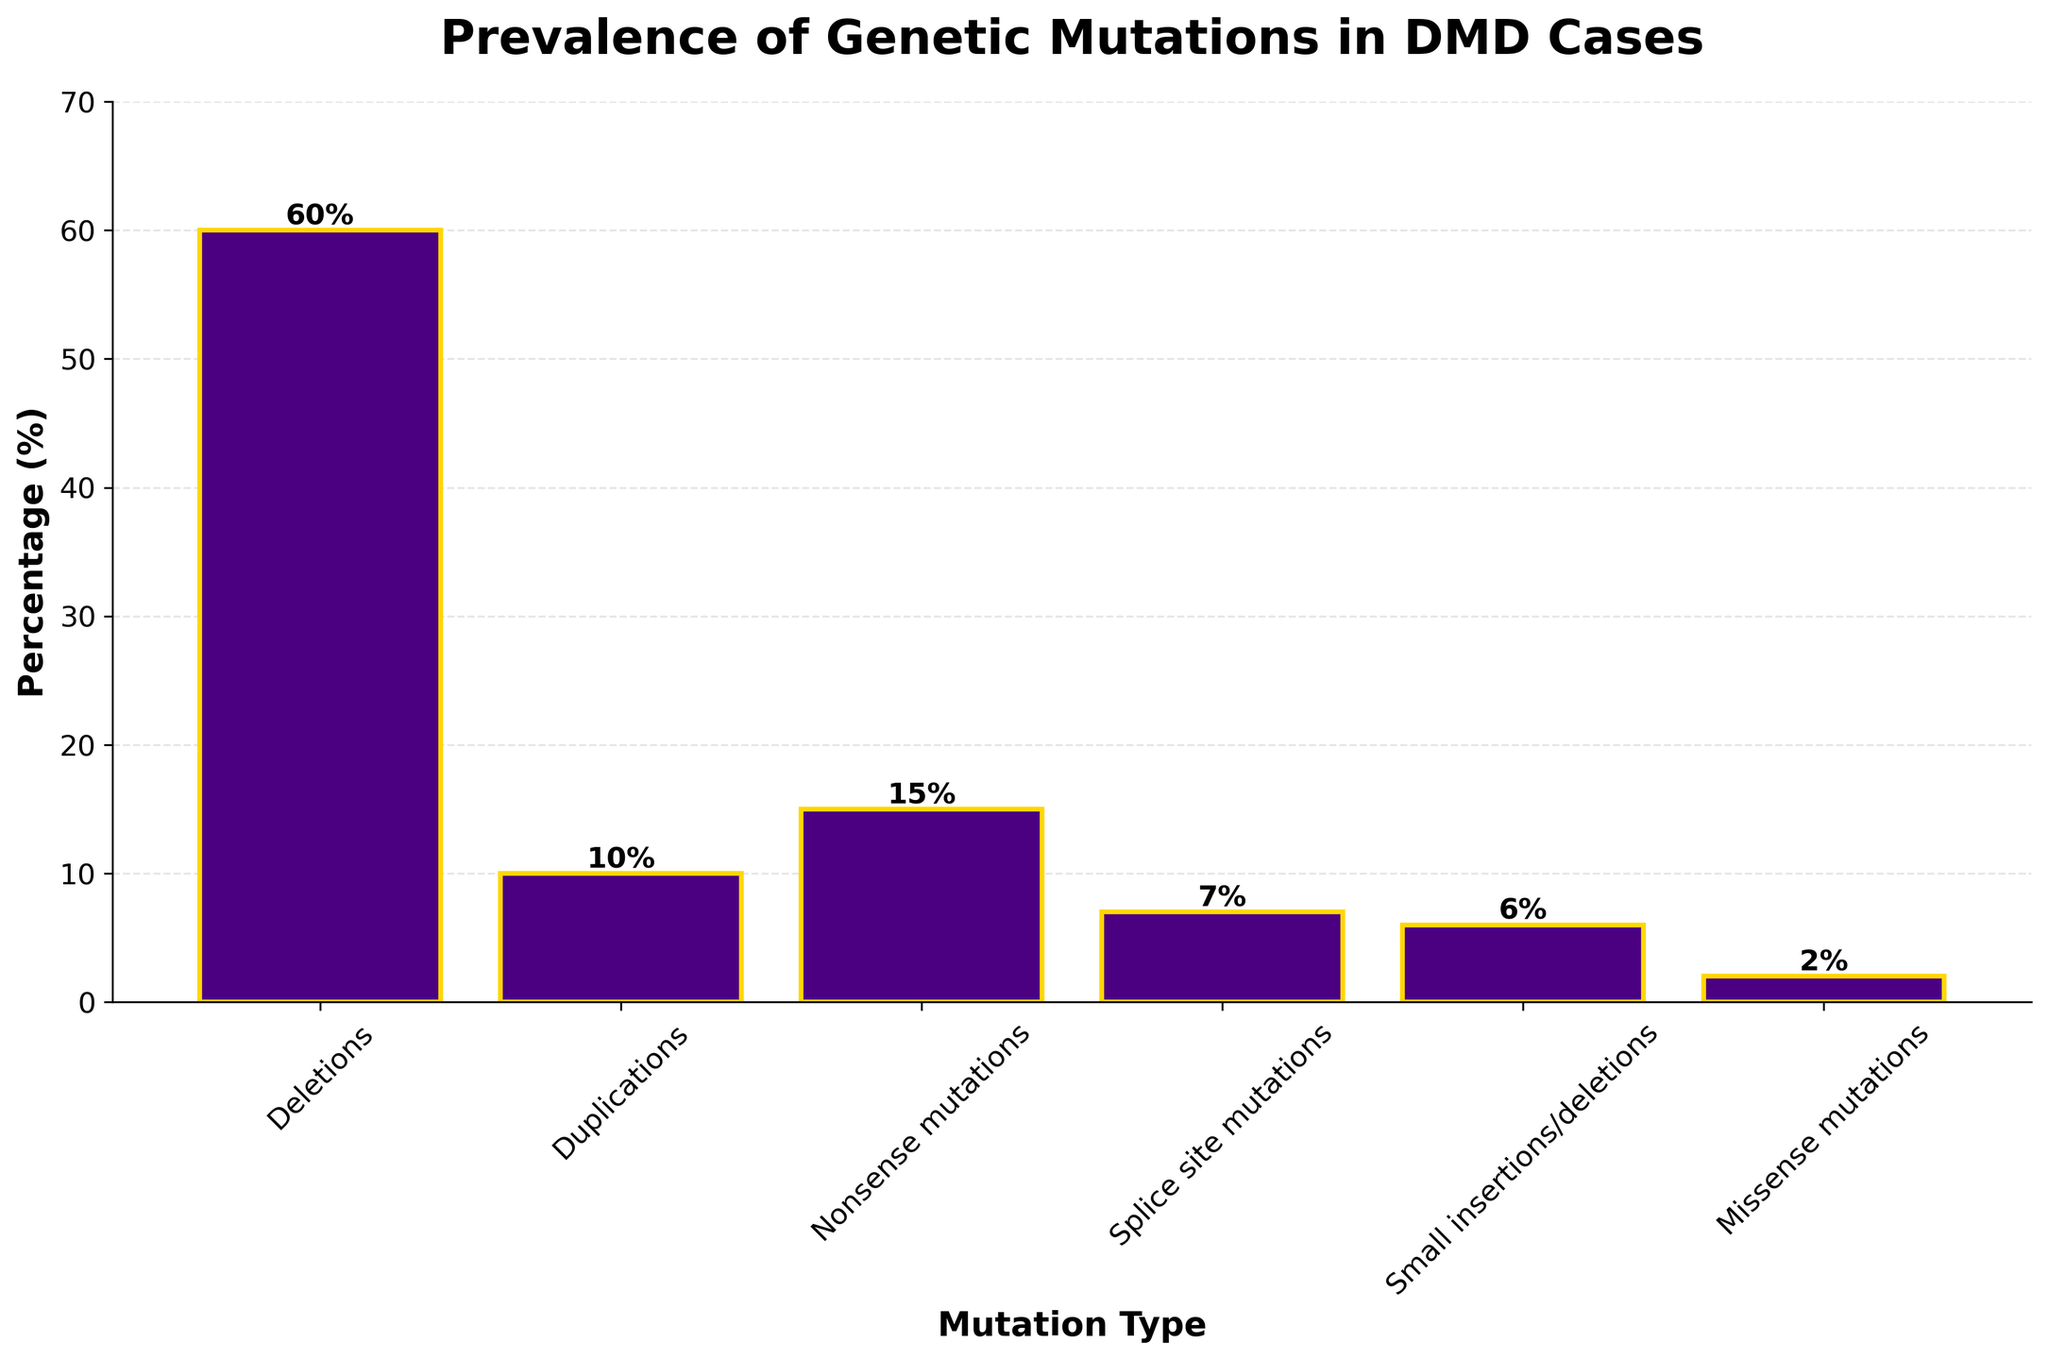Which mutation type has the highest prevalence in DMD cases? By examining the heights of all the bars, the bar representing "Deletions" is the tallest, indicating the highest prevalence.
Answer: Deletions What's the combined prevalence of Nonsense mutations and Splice site mutations? Adding the percentage values for Nonsense mutations (15%) and Splice site mutations (7%) gives the combined prevalence. 15% + 7% = 22%
Answer: 22% How does the prevalence of Duplications compare to that of Small insertions/deletions? The percentage for Duplications is 10%, while for Small insertions/deletions it is 6%. Comparing these, Duplications have a higher prevalence.
Answer: Duplications have a higher prevalence What is the difference in prevalence between Deletions and Missense mutations? The percentage for Deletions is 60% and for Missense mutations is 2%. Subtracting these values gives 60% - 2% = 58%.
Answer: 58% Which two mutation types have a combined prevalence equal to that of Deletions? Deletions have a prevalence of 60%. The combined prevalence of Nonsense mutations (15%) and Duplications (10%) falls short at 25%, as do other combinations. Adding the prevalence of Duplications (10%), Nonsense mutations (15%), Splice site mutations (7%), Small insertions/deletions (6%), and Missense mutations (2%); no relevant combinations exactly match 60%.
Answer: No exact match What's the average prevalence of all mutation types? To find the average prevalence, sum all percentages and divide by the number of mutation types. (60% + 10% + 15% + 7% + 6% + 2%) = 100%. There are six mutation types, so the average is 100% ÷ 6 ≈ 16.67%.
Answer: 16.67% Is the prevalence of Duplications lower than the combined prevalence of Splice site mutations and Missense mutations? The percentage for Duplications is 10%. The combined percentage for Splice site mutations (7%) and Missense mutations (2%) is 9%. Since 10% > 9%, the prevalence of Duplications is not lower.
Answer: No What proportion of the total prevalence is attributed to Small insertions/deletions? The percentage for Small insertions/deletions is 6%, and the total percentage is 100%. Therefore, the proportion is 6%/100% which is 6%.
Answer: 6% Does any mutation type have a prevalence below 5%? By examining the percentages, all mutation types have a prevalence of at least 2% or higher.
Answer: No Which mutation types have similar prevalences? Deletions (60%) and other types differ significantly, but Duplications (10%), Splice site mutations (7%), and Small insertions/deletions (6%) have percentages within a small range of each other.
Answer: Duplications, Splice site mutations, Small insertions/deletions 